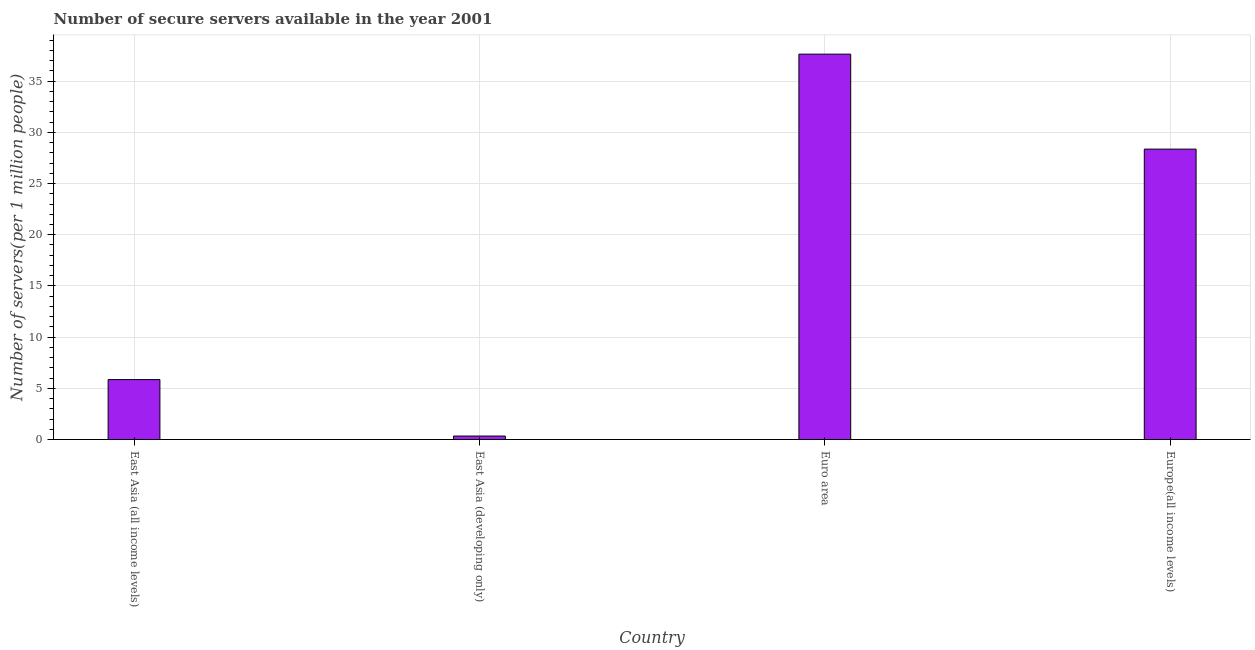Does the graph contain any zero values?
Provide a short and direct response. No. Does the graph contain grids?
Keep it short and to the point. Yes. What is the title of the graph?
Offer a very short reply. Number of secure servers available in the year 2001. What is the label or title of the Y-axis?
Your answer should be very brief. Number of servers(per 1 million people). What is the number of secure internet servers in Europe(all income levels)?
Make the answer very short. 28.36. Across all countries, what is the maximum number of secure internet servers?
Your answer should be very brief. 37.64. Across all countries, what is the minimum number of secure internet servers?
Your answer should be compact. 0.34. In which country was the number of secure internet servers maximum?
Provide a short and direct response. Euro area. In which country was the number of secure internet servers minimum?
Ensure brevity in your answer.  East Asia (developing only). What is the sum of the number of secure internet servers?
Offer a very short reply. 72.19. What is the difference between the number of secure internet servers in Euro area and Europe(all income levels)?
Provide a succinct answer. 9.28. What is the average number of secure internet servers per country?
Make the answer very short. 18.05. What is the median number of secure internet servers?
Offer a very short reply. 17.11. What is the ratio of the number of secure internet servers in East Asia (all income levels) to that in Euro area?
Your response must be concise. 0.15. Is the number of secure internet servers in Euro area less than that in Europe(all income levels)?
Your answer should be very brief. No. What is the difference between the highest and the second highest number of secure internet servers?
Make the answer very short. 9.28. Is the sum of the number of secure internet servers in East Asia (developing only) and Europe(all income levels) greater than the maximum number of secure internet servers across all countries?
Give a very brief answer. No. What is the difference between the highest and the lowest number of secure internet servers?
Your answer should be compact. 37.3. In how many countries, is the number of secure internet servers greater than the average number of secure internet servers taken over all countries?
Provide a short and direct response. 2. How many bars are there?
Keep it short and to the point. 4. Are all the bars in the graph horizontal?
Ensure brevity in your answer.  No. How many countries are there in the graph?
Give a very brief answer. 4. What is the difference between two consecutive major ticks on the Y-axis?
Provide a short and direct response. 5. What is the Number of servers(per 1 million people) of East Asia (all income levels)?
Offer a very short reply. 5.85. What is the Number of servers(per 1 million people) in East Asia (developing only)?
Ensure brevity in your answer.  0.34. What is the Number of servers(per 1 million people) of Euro area?
Give a very brief answer. 37.64. What is the Number of servers(per 1 million people) in Europe(all income levels)?
Provide a succinct answer. 28.36. What is the difference between the Number of servers(per 1 million people) in East Asia (all income levels) and East Asia (developing only)?
Offer a very short reply. 5.51. What is the difference between the Number of servers(per 1 million people) in East Asia (all income levels) and Euro area?
Offer a very short reply. -31.79. What is the difference between the Number of servers(per 1 million people) in East Asia (all income levels) and Europe(all income levels)?
Make the answer very short. -22.51. What is the difference between the Number of servers(per 1 million people) in East Asia (developing only) and Euro area?
Make the answer very short. -37.3. What is the difference between the Number of servers(per 1 million people) in East Asia (developing only) and Europe(all income levels)?
Keep it short and to the point. -28.02. What is the difference between the Number of servers(per 1 million people) in Euro area and Europe(all income levels)?
Provide a short and direct response. 9.28. What is the ratio of the Number of servers(per 1 million people) in East Asia (all income levels) to that in East Asia (developing only)?
Your answer should be very brief. 17.19. What is the ratio of the Number of servers(per 1 million people) in East Asia (all income levels) to that in Euro area?
Offer a terse response. 0.15. What is the ratio of the Number of servers(per 1 million people) in East Asia (all income levels) to that in Europe(all income levels)?
Give a very brief answer. 0.21. What is the ratio of the Number of servers(per 1 million people) in East Asia (developing only) to that in Euro area?
Offer a very short reply. 0.01. What is the ratio of the Number of servers(per 1 million people) in East Asia (developing only) to that in Europe(all income levels)?
Your response must be concise. 0.01. What is the ratio of the Number of servers(per 1 million people) in Euro area to that in Europe(all income levels)?
Ensure brevity in your answer.  1.33. 